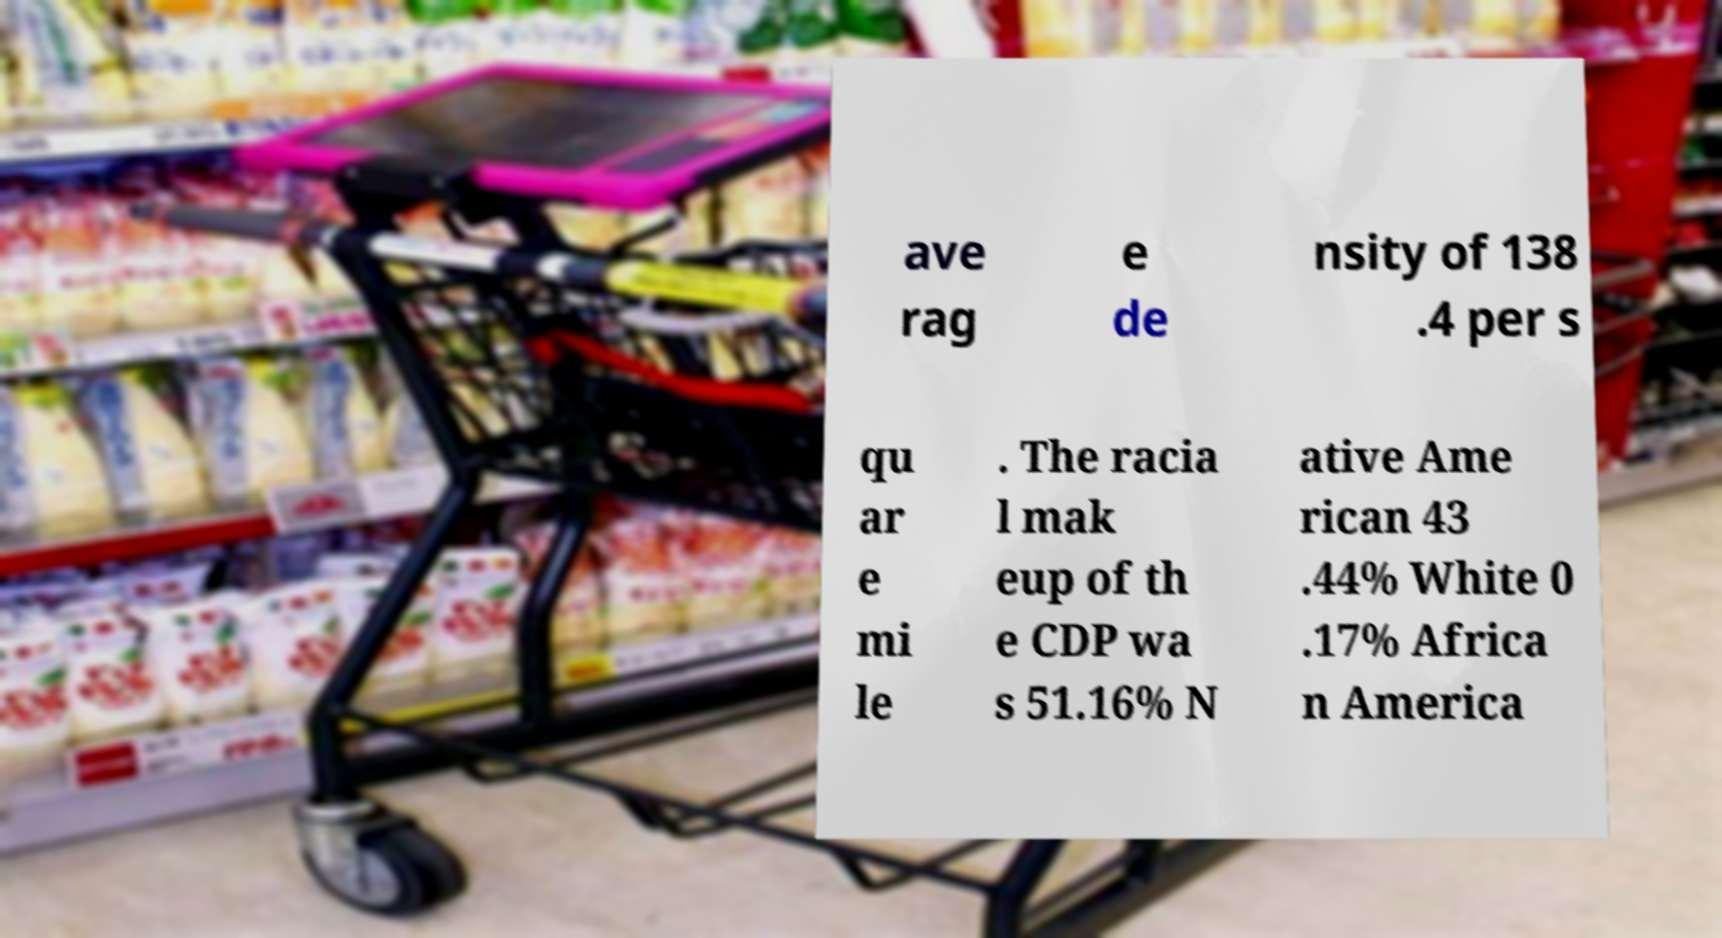Please read and relay the text visible in this image. What does it say? ave rag e de nsity of 138 .4 per s qu ar e mi le . The racia l mak eup of th e CDP wa s 51.16% N ative Ame rican 43 .44% White 0 .17% Africa n America 